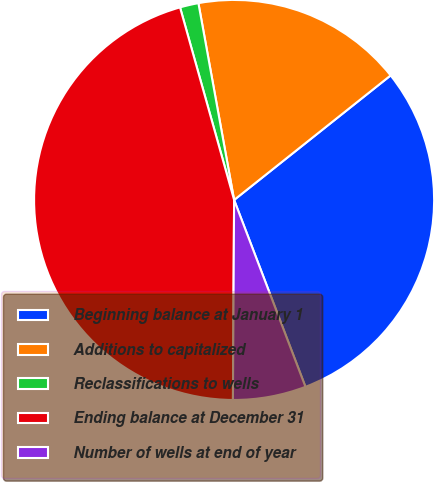<chart> <loc_0><loc_0><loc_500><loc_500><pie_chart><fcel>Beginning balance at January 1<fcel>Additions to capitalized<fcel>Reclassifications to wells<fcel>Ending balance at December 31<fcel>Number of wells at end of year<nl><fcel>29.89%<fcel>17.16%<fcel>1.5%<fcel>45.55%<fcel>5.9%<nl></chart> 